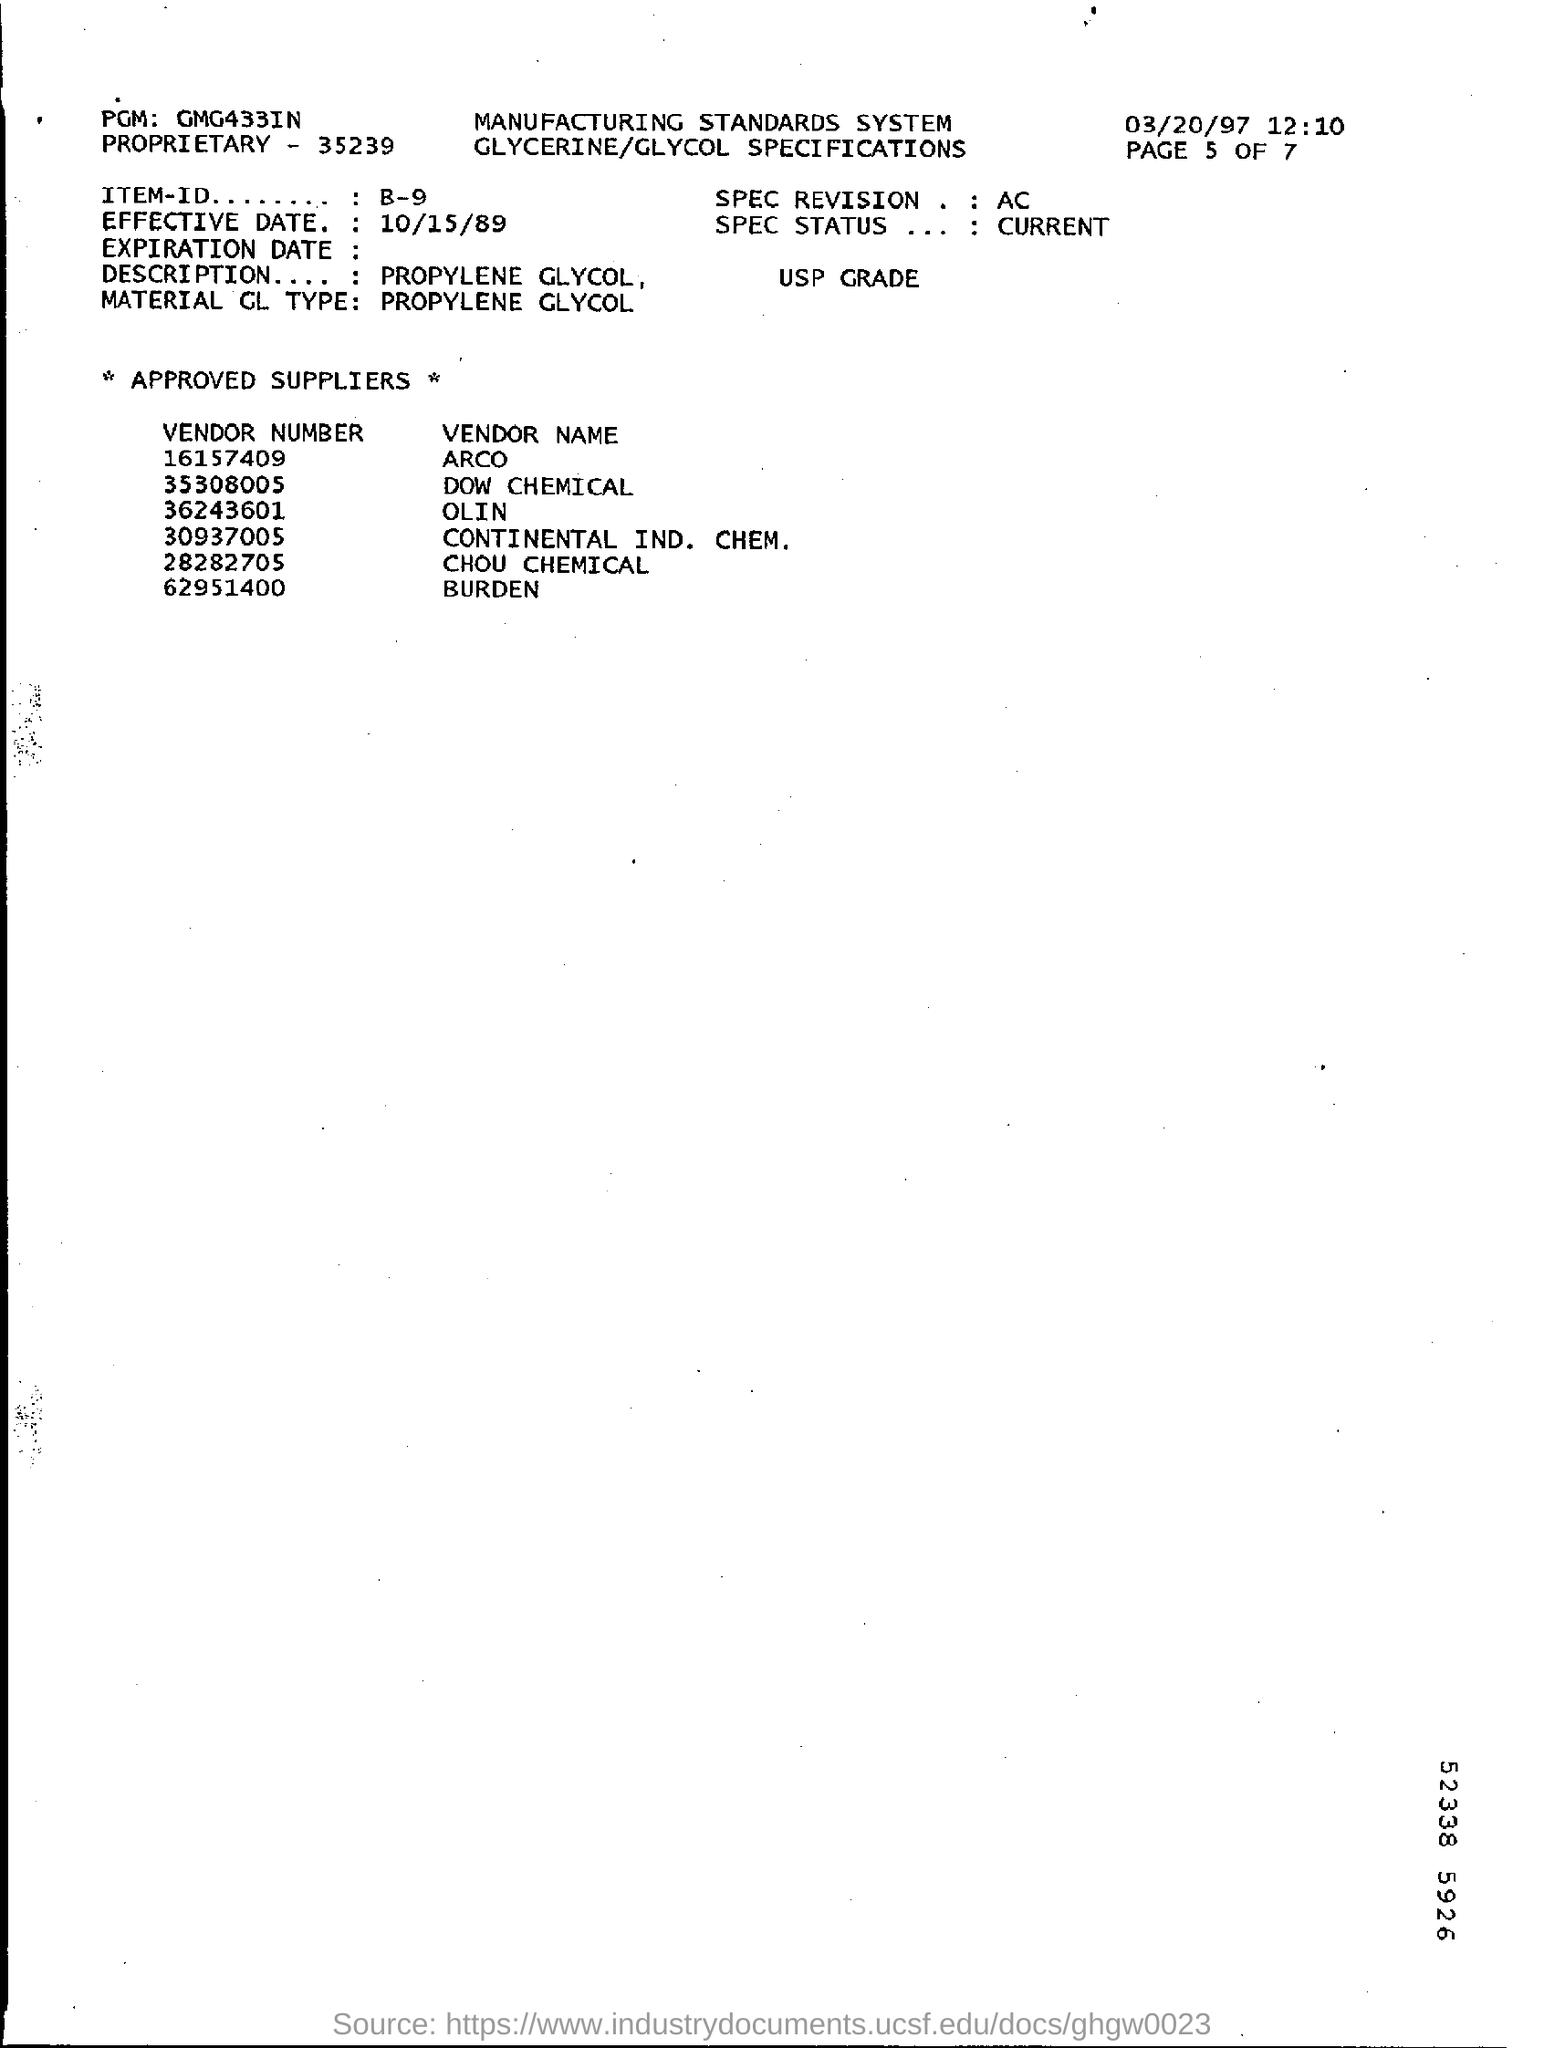Specify some key components in this picture. Can you please provide the item ID? It is B-9... The effective date of 10/15/89 has been declared. The material being referred to is Propylene Glycol. The vendor corresponding to 62951400 is BURDEN. The vendor number of Dow Chemical is 35308005. 